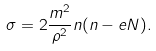<formula> <loc_0><loc_0><loc_500><loc_500>\sigma = 2 \frac { m ^ { 2 } } { \rho ^ { 2 } } n ( n - e N ) .</formula> 